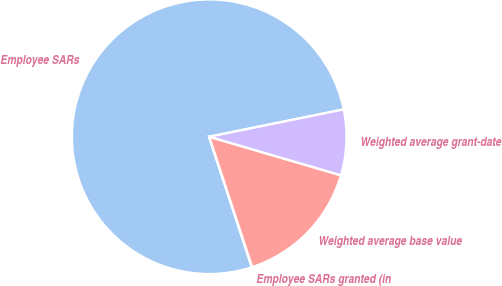<chart> <loc_0><loc_0><loc_500><loc_500><pie_chart><fcel>Employee SARs<fcel>Employee SARs granted (in<fcel>Weighted average base value<fcel>Weighted average grant-date<nl><fcel>76.84%<fcel>0.04%<fcel>15.4%<fcel>7.72%<nl></chart> 